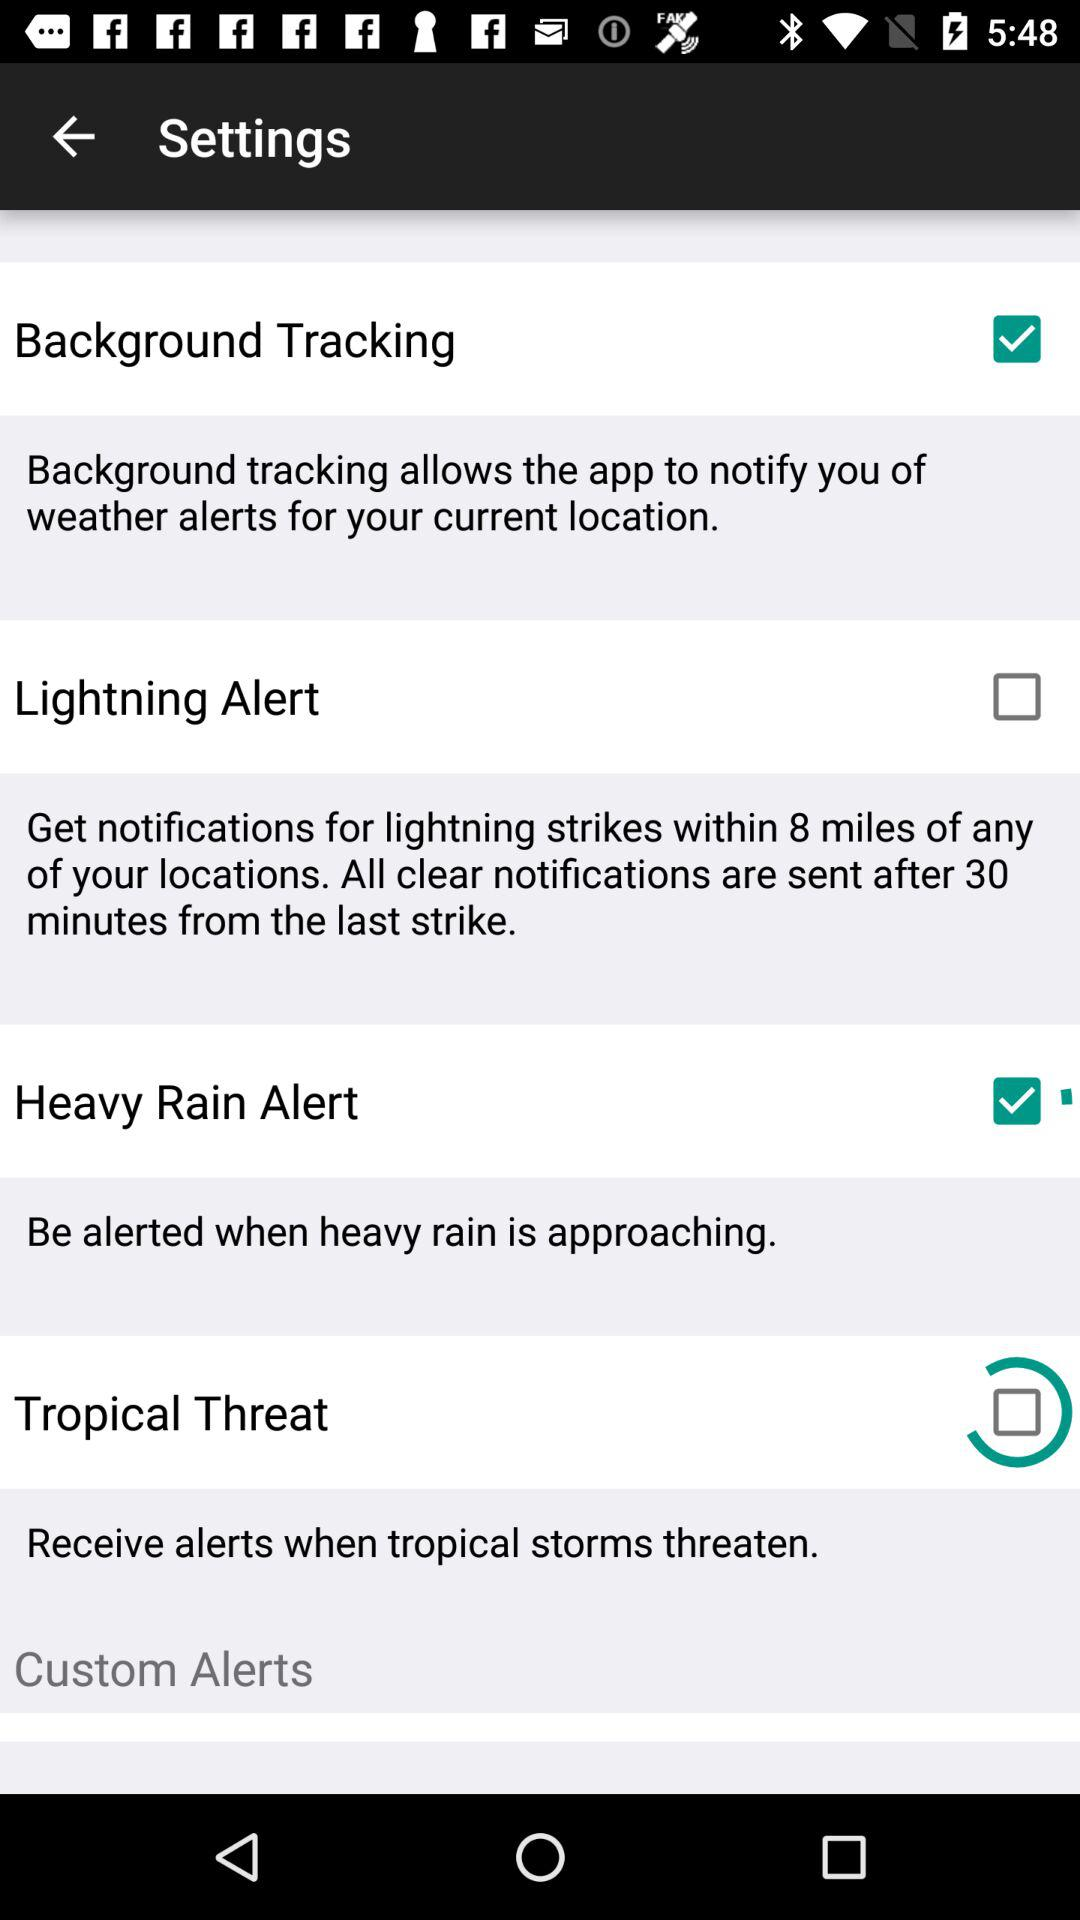What's the radius for getting lightning strike notifications near any of your locations? The radius for getting lightning strike notifications is within 8 miles. 